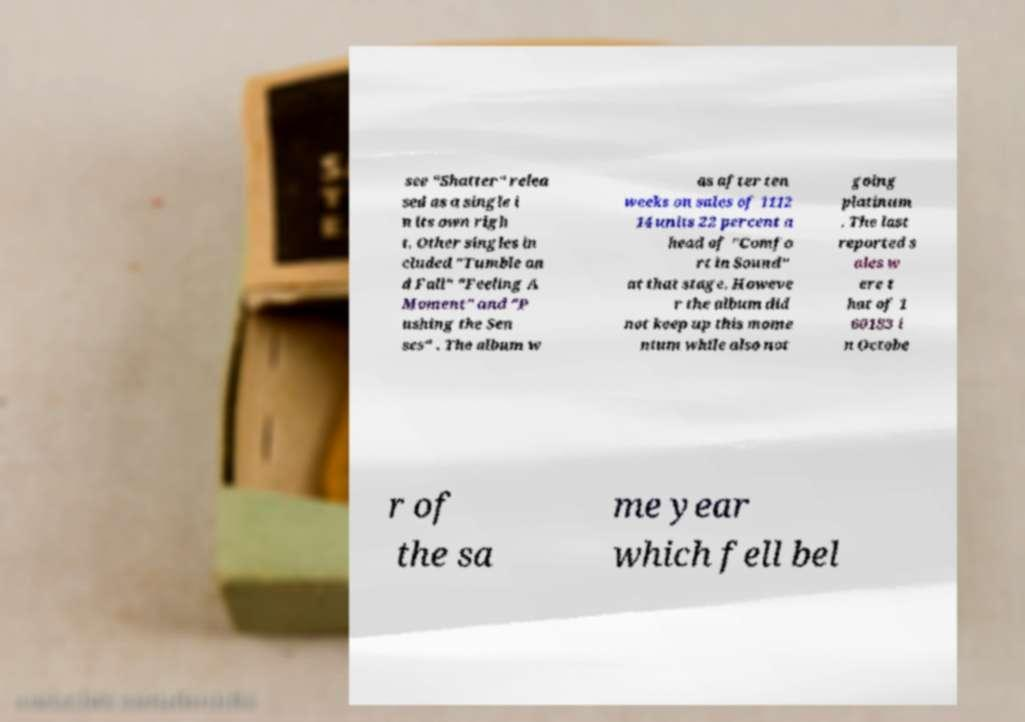Can you read and provide the text displayed in the image?This photo seems to have some interesting text. Can you extract and type it out for me? see "Shatter" relea sed as a single i n its own righ t. Other singles in cluded "Tumble an d Fall" "Feeling A Moment" and "P ushing the Sen ses" . The album w as after ten weeks on sales of 1112 14 units 22 percent a head of "Comfo rt in Sound" at that stage. Howeve r the album did not keep up this mome ntum while also not going platinum . The last reported s ales w ere t hat of 1 60183 i n Octobe r of the sa me year which fell bel 